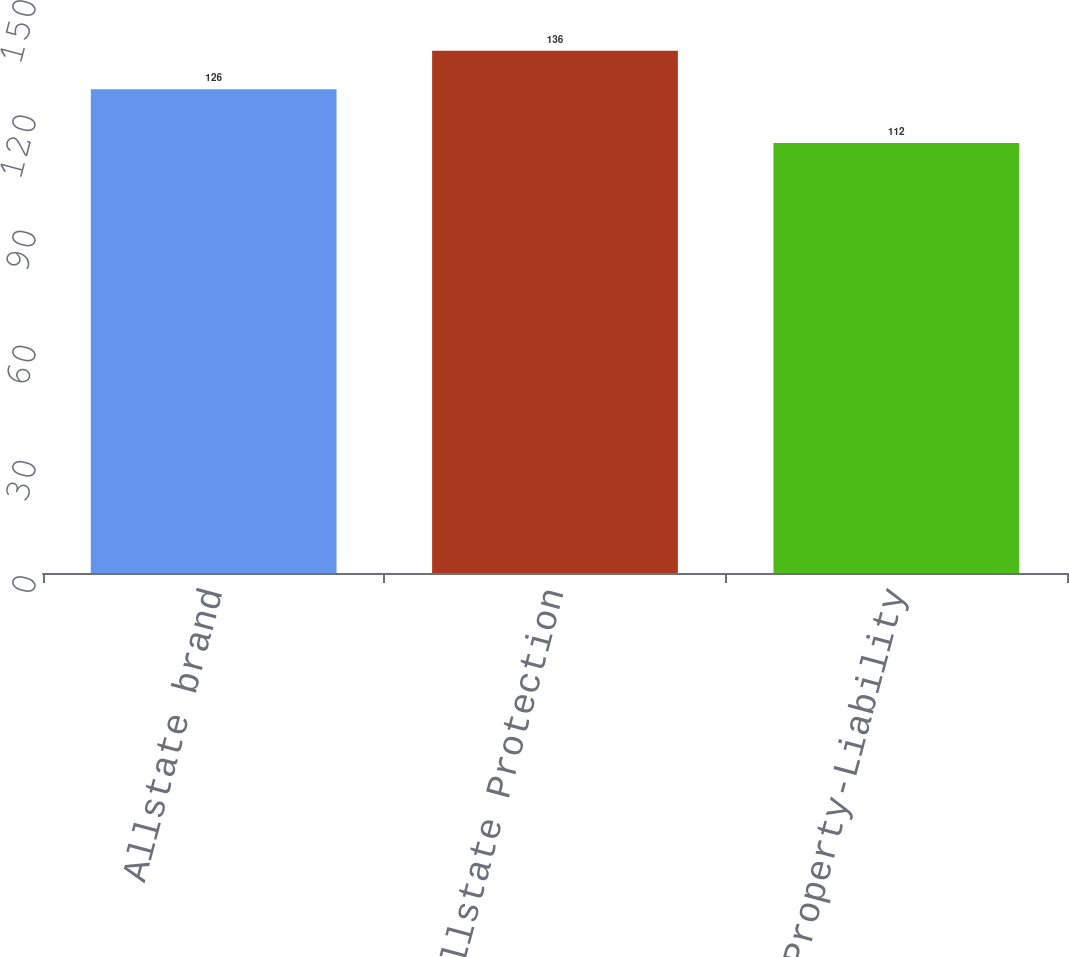Convert chart to OTSL. <chart><loc_0><loc_0><loc_500><loc_500><bar_chart><fcel>Allstate brand<fcel>Total Allstate Protection<fcel>Total Property-Liability<nl><fcel>126<fcel>136<fcel>112<nl></chart> 